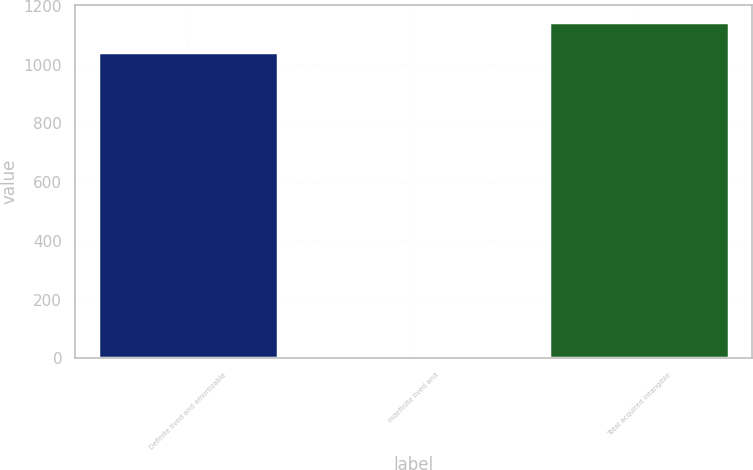<chart> <loc_0><loc_0><loc_500><loc_500><bar_chart><fcel>Definite lived and amortizable<fcel>Indefinite lived and<fcel>Total acquired intangible<nl><fcel>1042<fcel>1.57<fcel>1146.04<nl></chart> 